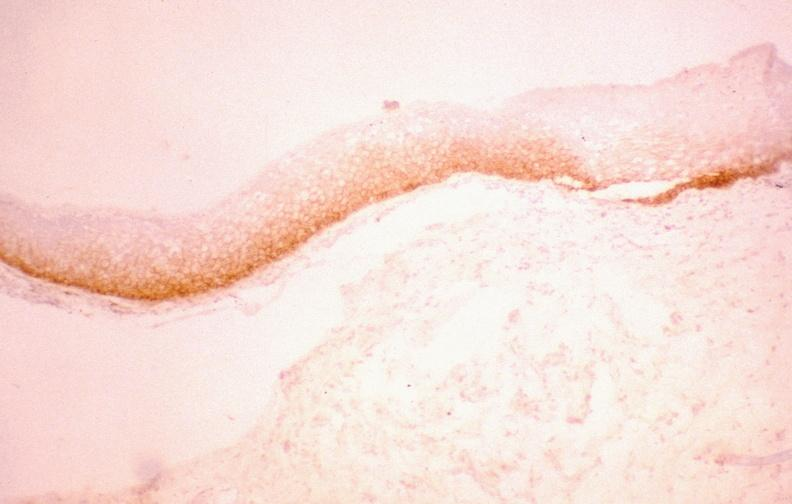what does this image show?
Answer the question using a single word or phrase. Oral dysplasia 